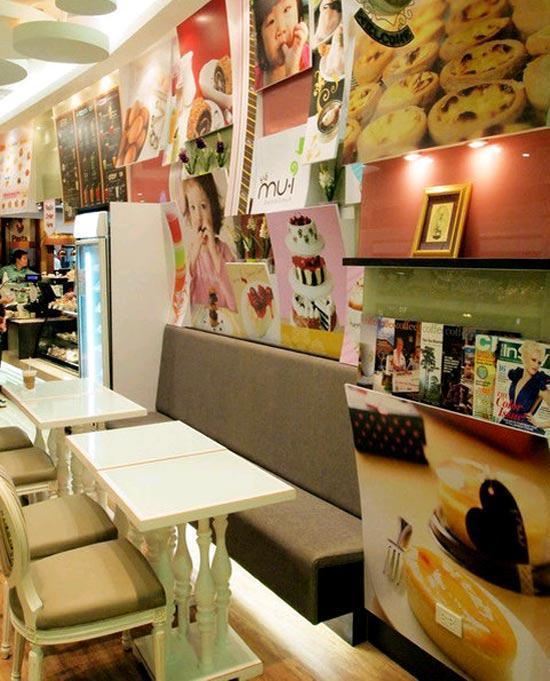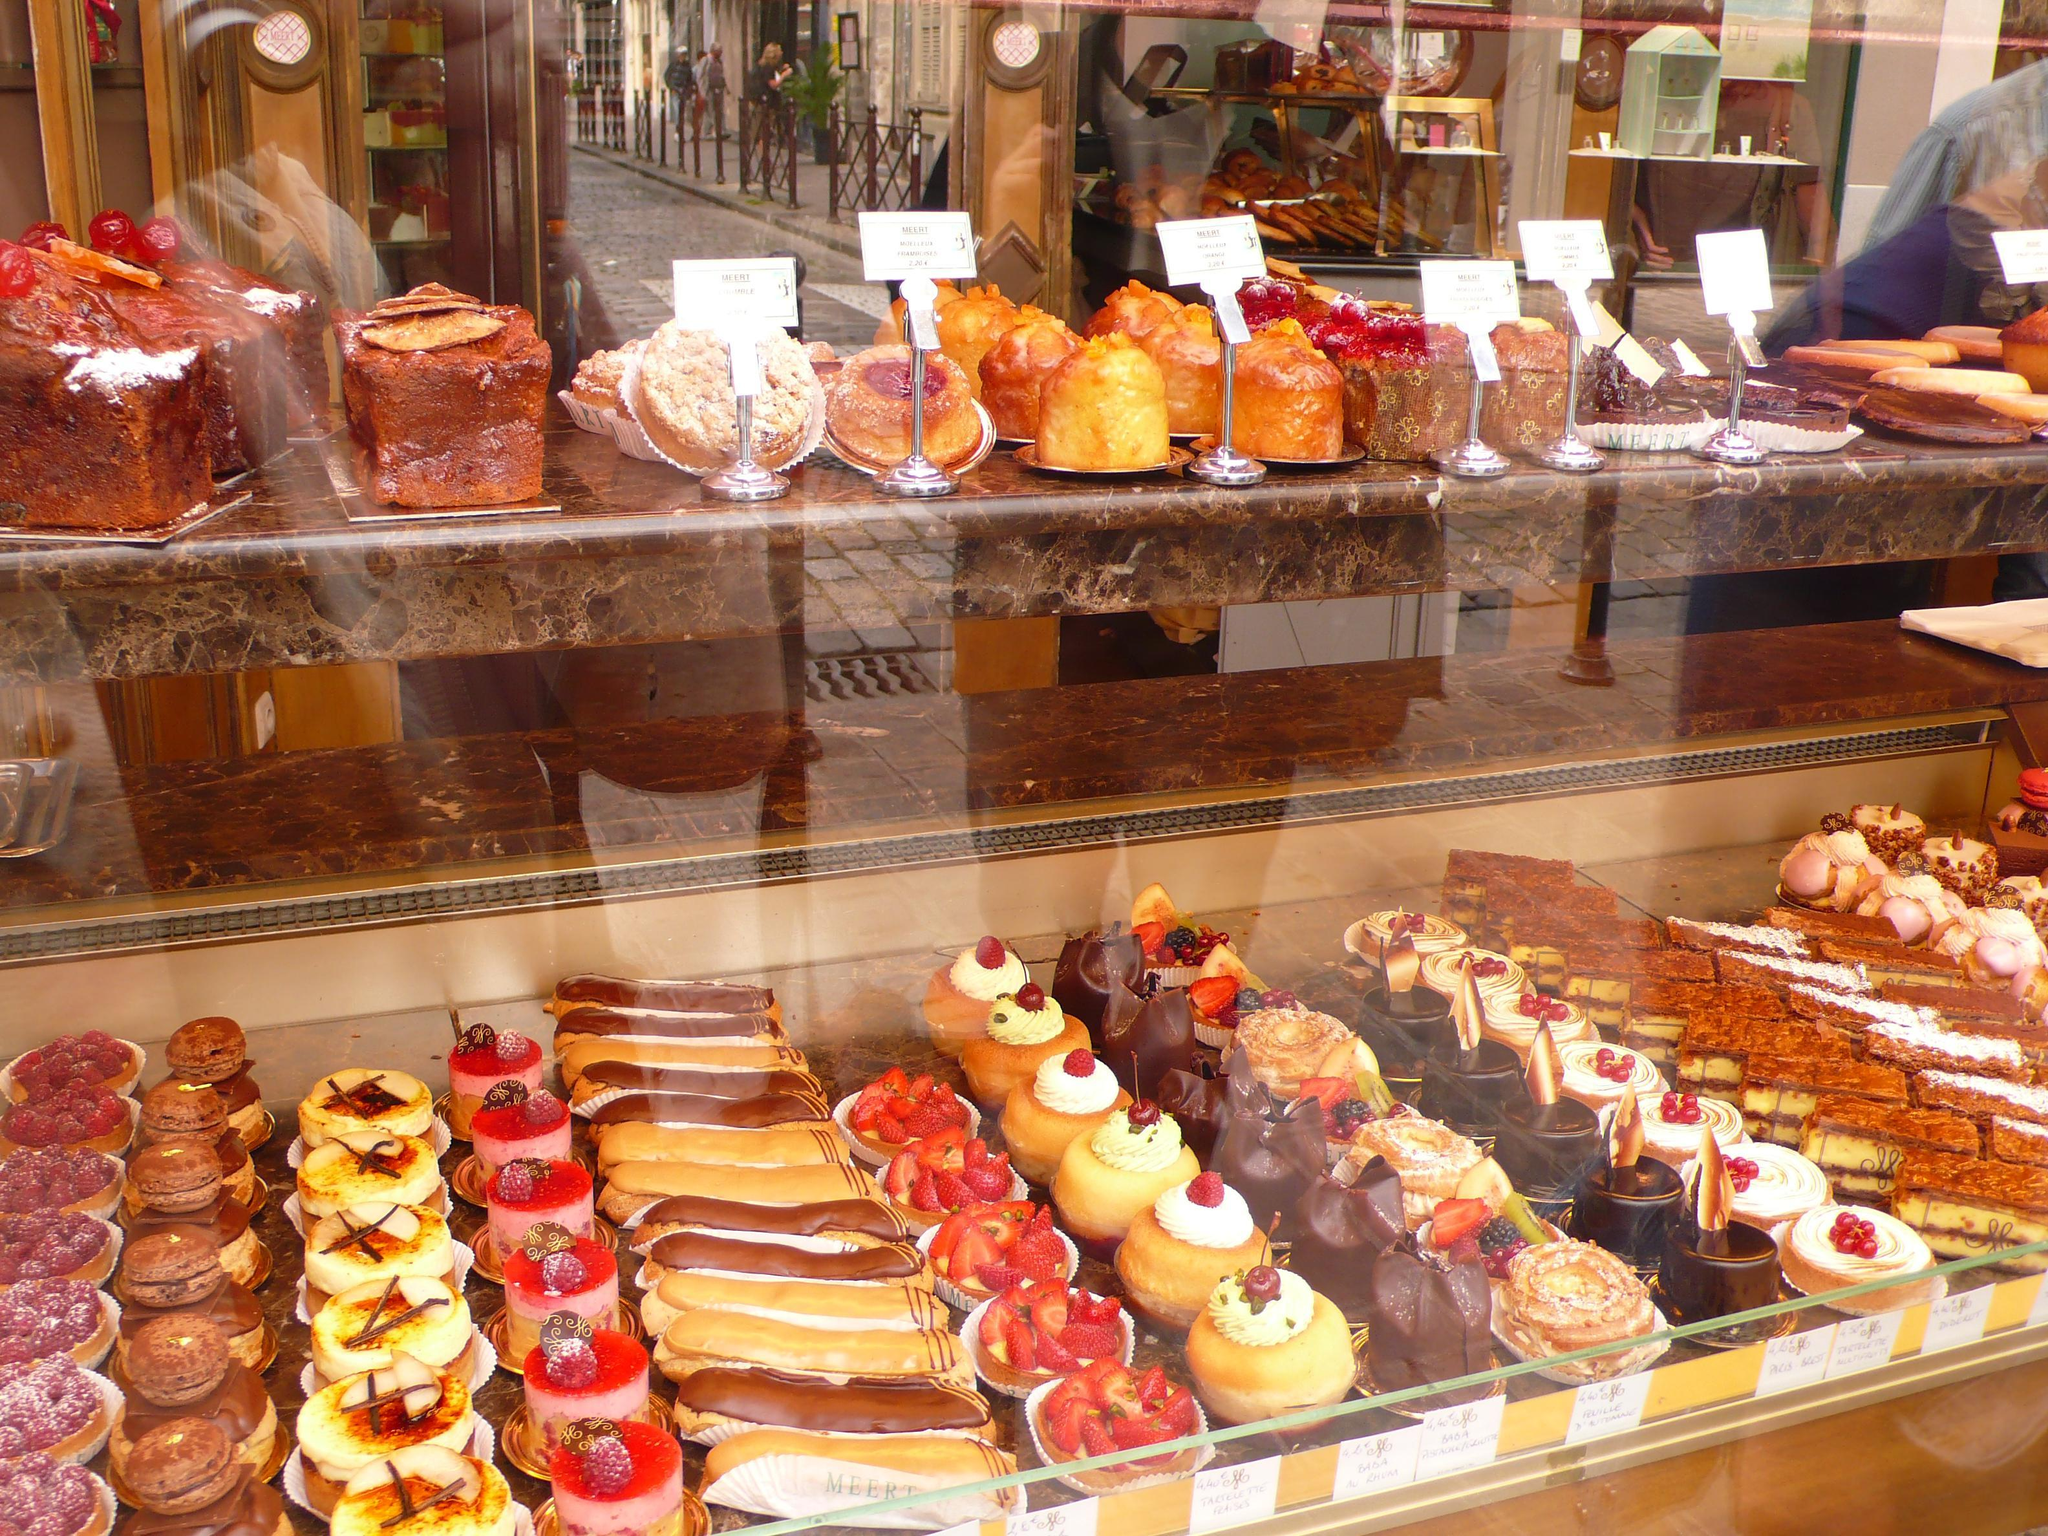The first image is the image on the left, the second image is the image on the right. For the images displayed, is the sentence "A bakery in one image has a seating area with tables and chairs where patrons can sit and enjoy the food and drinks they buy." factually correct? Answer yes or no. Yes. The first image is the image on the left, the second image is the image on the right. Evaluate the accuracy of this statement regarding the images: "The decor of one bakery features a colorful suspended light with a round shape.". Is it true? Answer yes or no. No. 